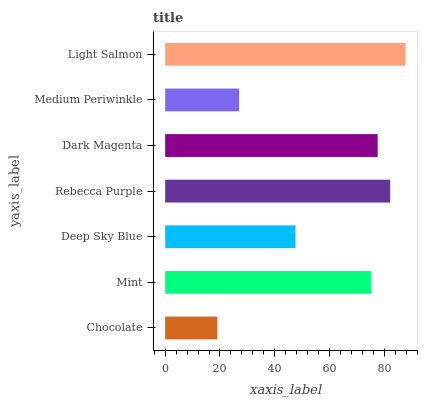Is Chocolate the minimum?
Answer yes or no. Yes. Is Light Salmon the maximum?
Answer yes or no. Yes. Is Mint the minimum?
Answer yes or no. No. Is Mint the maximum?
Answer yes or no. No. Is Mint greater than Chocolate?
Answer yes or no. Yes. Is Chocolate less than Mint?
Answer yes or no. Yes. Is Chocolate greater than Mint?
Answer yes or no. No. Is Mint less than Chocolate?
Answer yes or no. No. Is Mint the high median?
Answer yes or no. Yes. Is Mint the low median?
Answer yes or no. Yes. Is Dark Magenta the high median?
Answer yes or no. No. Is Medium Periwinkle the low median?
Answer yes or no. No. 